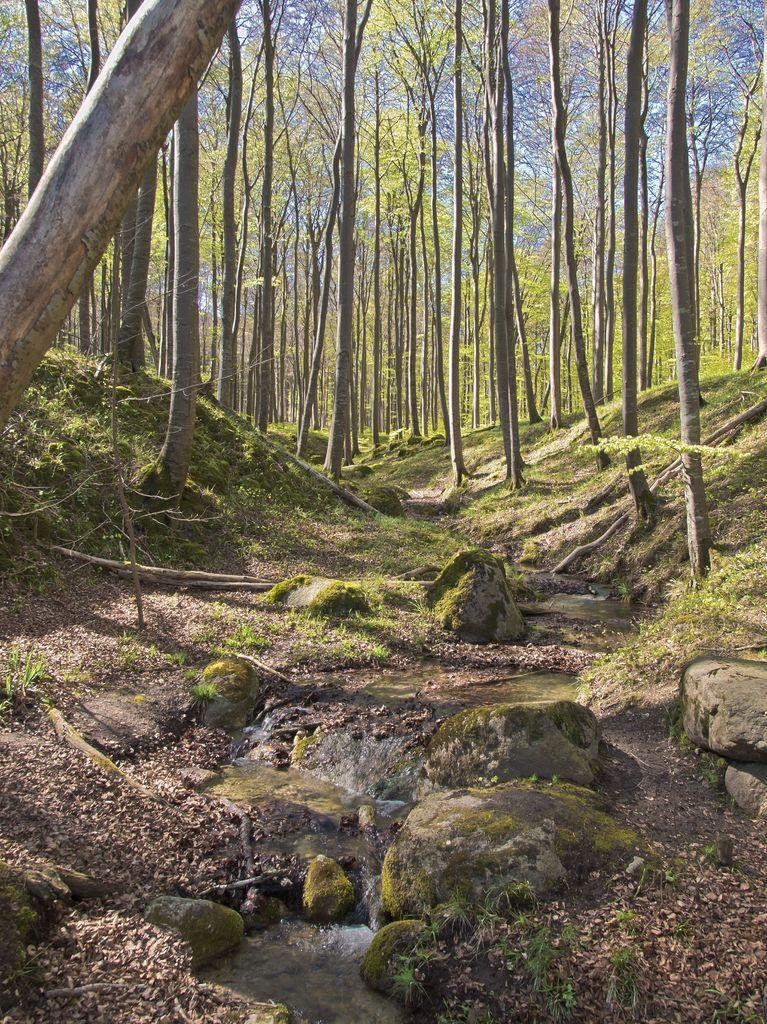What type of vegetation is visible in the image? There are many trees in the image. What natural element can be seen at the bottom of the image? There is water visible at the bottom of the image. What type of geological formation is present in the image? There are rocks present in the image. Can you tell me how many apples are hanging from the trees in the image? There is no mention of apples in the image; it features trees, water, and rocks. What type of nut can be seen growing on the rocks in the image? There is no nut present in the image; it only features trees, water, and rocks. 